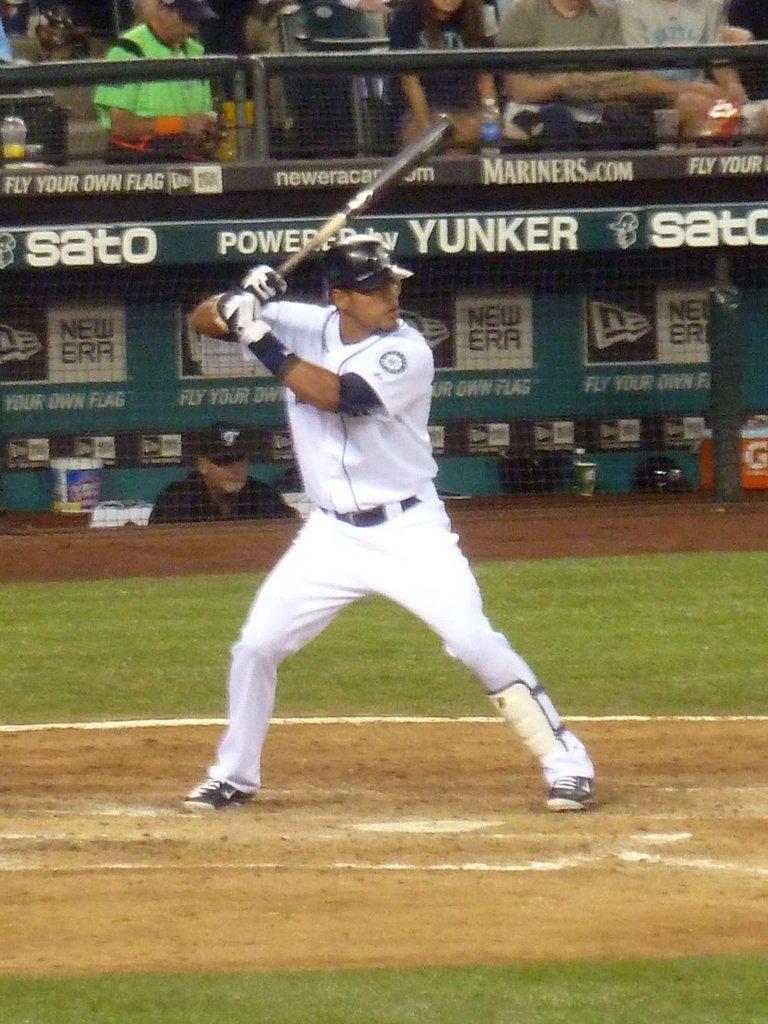What is the name of the company that starts with a y on the board?
Give a very brief answer. Yunker. What sportswear company sponsors the dugout?
Provide a short and direct response. New era. 